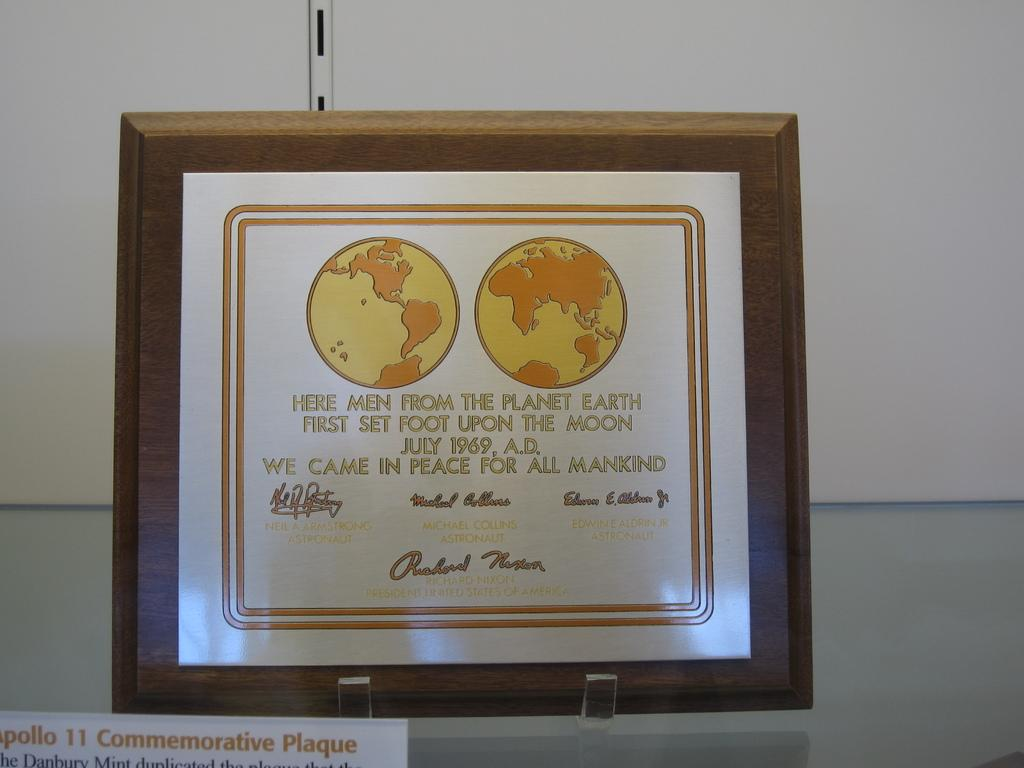Provide a one-sentence caption for the provided image. Men from earth set foot on the moon in July. 